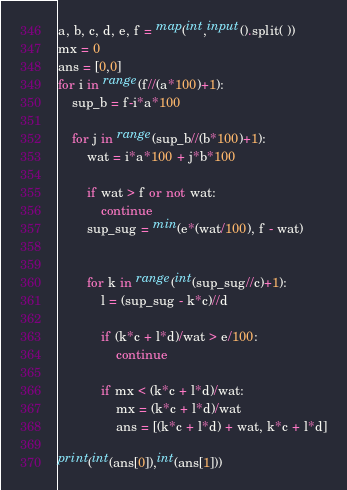Convert code to text. <code><loc_0><loc_0><loc_500><loc_500><_Python_>a, b, c, d, e, f = map(int,input().split( ))
mx = 0
ans = [0,0]
for i in range(f//(a*100)+1):
    sup_b = f-i*a*100
    
    for j in range(sup_b//(b*100)+1):
        wat = i*a*100 + j*b*100
        
        if wat > f or not wat:
            continue
        sup_sug = min(e*(wat/100), f - wat)

        
        for k in range(int(sup_sug//c)+1):
            l = (sup_sug - k*c)//d
            
            if (k*c + l*d)/wat > e/100:
                continue
                
            if mx < (k*c + l*d)/wat:
                mx = (k*c + l*d)/wat
                ans = [(k*c + l*d) + wat, k*c + l*d]

print(int(ans[0]),int(ans[1]))
</code> 